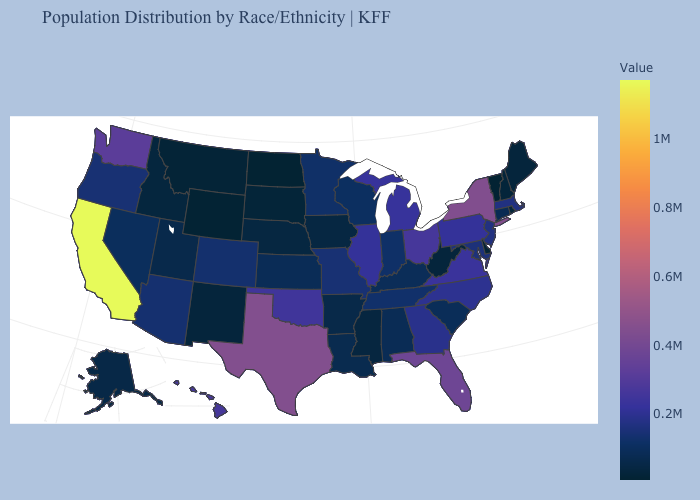Among the states that border Colorado , does Oklahoma have the highest value?
Be succinct. Yes. Among the states that border Delaware , does Maryland have the highest value?
Quick response, please. No. Among the states that border Wyoming , does Montana have the lowest value?
Write a very short answer. Yes. Is the legend a continuous bar?
Short answer required. Yes. Does Montana have a lower value than Massachusetts?
Short answer required. Yes. 